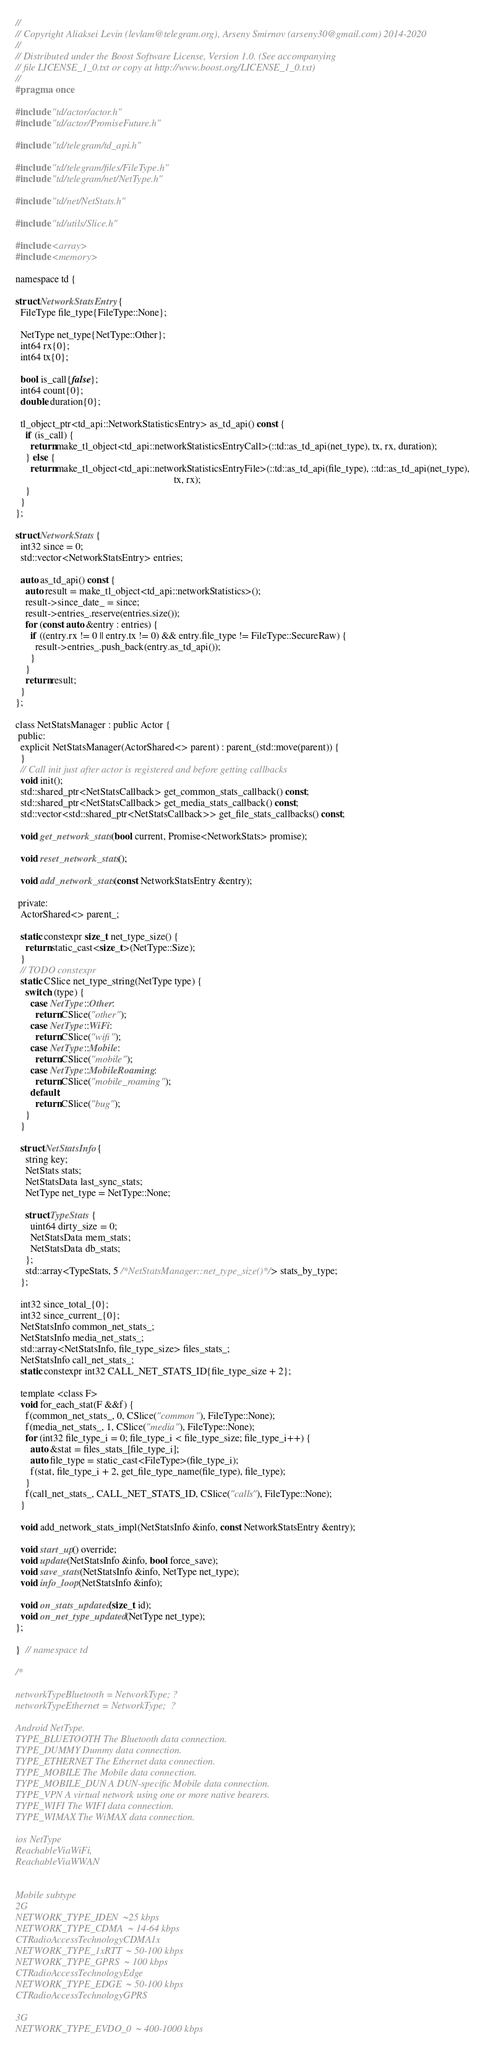<code> <loc_0><loc_0><loc_500><loc_500><_C_>//
// Copyright Aliaksei Levin (levlam@telegram.org), Arseny Smirnov (arseny30@gmail.com) 2014-2020
//
// Distributed under the Boost Software License, Version 1.0. (See accompanying
// file LICENSE_1_0.txt or copy at http://www.boost.org/LICENSE_1_0.txt)
//
#pragma once

#include "td/actor/actor.h"
#include "td/actor/PromiseFuture.h"

#include "td/telegram/td_api.h"

#include "td/telegram/files/FileType.h"
#include "td/telegram/net/NetType.h"

#include "td/net/NetStats.h"

#include "td/utils/Slice.h"

#include <array>
#include <memory>

namespace td {

struct NetworkStatsEntry {
  FileType file_type{FileType::None};

  NetType net_type{NetType::Other};
  int64 rx{0};
  int64 tx{0};

  bool is_call{false};
  int64 count{0};
  double duration{0};

  tl_object_ptr<td_api::NetworkStatisticsEntry> as_td_api() const {
    if (is_call) {
      return make_tl_object<td_api::networkStatisticsEntryCall>(::td::as_td_api(net_type), tx, rx, duration);
    } else {
      return make_tl_object<td_api::networkStatisticsEntryFile>(::td::as_td_api(file_type), ::td::as_td_api(net_type),
                                                                tx, rx);
    }
  }
};

struct NetworkStats {
  int32 since = 0;
  std::vector<NetworkStatsEntry> entries;

  auto as_td_api() const {
    auto result = make_tl_object<td_api::networkStatistics>();
    result->since_date_ = since;
    result->entries_.reserve(entries.size());
    for (const auto &entry : entries) {
      if ((entry.rx != 0 || entry.tx != 0) && entry.file_type != FileType::SecureRaw) {
        result->entries_.push_back(entry.as_td_api());
      }
    }
    return result;
  }
};

class NetStatsManager : public Actor {
 public:
  explicit NetStatsManager(ActorShared<> parent) : parent_(std::move(parent)) {
  }
  // Call init just after actor is registered and before getting callbacks
  void init();
  std::shared_ptr<NetStatsCallback> get_common_stats_callback() const;
  std::shared_ptr<NetStatsCallback> get_media_stats_callback() const;
  std::vector<std::shared_ptr<NetStatsCallback>> get_file_stats_callbacks() const;

  void get_network_stats(bool current, Promise<NetworkStats> promise);

  void reset_network_stats();

  void add_network_stats(const NetworkStatsEntry &entry);

 private:
  ActorShared<> parent_;

  static constexpr size_t net_type_size() {
    return static_cast<size_t>(NetType::Size);
  }
  // TODO constexpr
  static CSlice net_type_string(NetType type) {
    switch (type) {
      case NetType::Other:
        return CSlice("other");
      case NetType::WiFi:
        return CSlice("wifi");
      case NetType::Mobile:
        return CSlice("mobile");
      case NetType::MobileRoaming:
        return CSlice("mobile_roaming");
      default:
        return CSlice("bug");
    }
  }

  struct NetStatsInfo {
    string key;
    NetStats stats;
    NetStatsData last_sync_stats;
    NetType net_type = NetType::None;

    struct TypeStats {
      uint64 dirty_size = 0;
      NetStatsData mem_stats;
      NetStatsData db_stats;
    };
    std::array<TypeStats, 5 /*NetStatsManager::net_type_size()*/> stats_by_type;
  };

  int32 since_total_{0};
  int32 since_current_{0};
  NetStatsInfo common_net_stats_;
  NetStatsInfo media_net_stats_;
  std::array<NetStatsInfo, file_type_size> files_stats_;
  NetStatsInfo call_net_stats_;
  static constexpr int32 CALL_NET_STATS_ID{file_type_size + 2};

  template <class F>
  void for_each_stat(F &&f) {
    f(common_net_stats_, 0, CSlice("common"), FileType::None);
    f(media_net_stats_, 1, CSlice("media"), FileType::None);
    for (int32 file_type_i = 0; file_type_i < file_type_size; file_type_i++) {
      auto &stat = files_stats_[file_type_i];
      auto file_type = static_cast<FileType>(file_type_i);
      f(stat, file_type_i + 2, get_file_type_name(file_type), file_type);
    }
    f(call_net_stats_, CALL_NET_STATS_ID, CSlice("calls"), FileType::None);
  }

  void add_network_stats_impl(NetStatsInfo &info, const NetworkStatsEntry &entry);

  void start_up() override;
  void update(NetStatsInfo &info, bool force_save);
  void save_stats(NetStatsInfo &info, NetType net_type);
  void info_loop(NetStatsInfo &info);

  void on_stats_updated(size_t id);
  void on_net_type_updated(NetType net_type);
};

}  // namespace td

/*

networkTypeBluetooth = NetworkType; ?
networkTypeEthernet = NetworkType;  ?

Android NetType.
TYPE_BLUETOOTH The Bluetooth data connection.
TYPE_DUMMY Dummy data connection.
TYPE_ETHERNET The Ethernet data connection.
TYPE_MOBILE The Mobile data connection.
TYPE_MOBILE_DUN A DUN-specific Mobile data connection.
TYPE_VPN A virtual network using one or more native bearers.
TYPE_WIFI The WIFI data connection.
TYPE_WIMAX The WiMAX data connection.

ios NetType
ReachableViaWiFi,
ReachableViaWWAN


Mobile subtype
2G
NETWORK_TYPE_IDEN  ~25 kbps
NETWORK_TYPE_CDMA  ~ 14-64 kbps
CTRadioAccessTechnologyCDMA1x
NETWORK_TYPE_1xRTT  ~ 50-100 kbps
NETWORK_TYPE_GPRS  ~ 100 kbps
CTRadioAccessTechnologyEdge
NETWORK_TYPE_EDGE  ~ 50-100 kbps
CTRadioAccessTechnologyGPRS

3G
NETWORK_TYPE_EVDO_0  ~ 400-1000 kbps</code> 